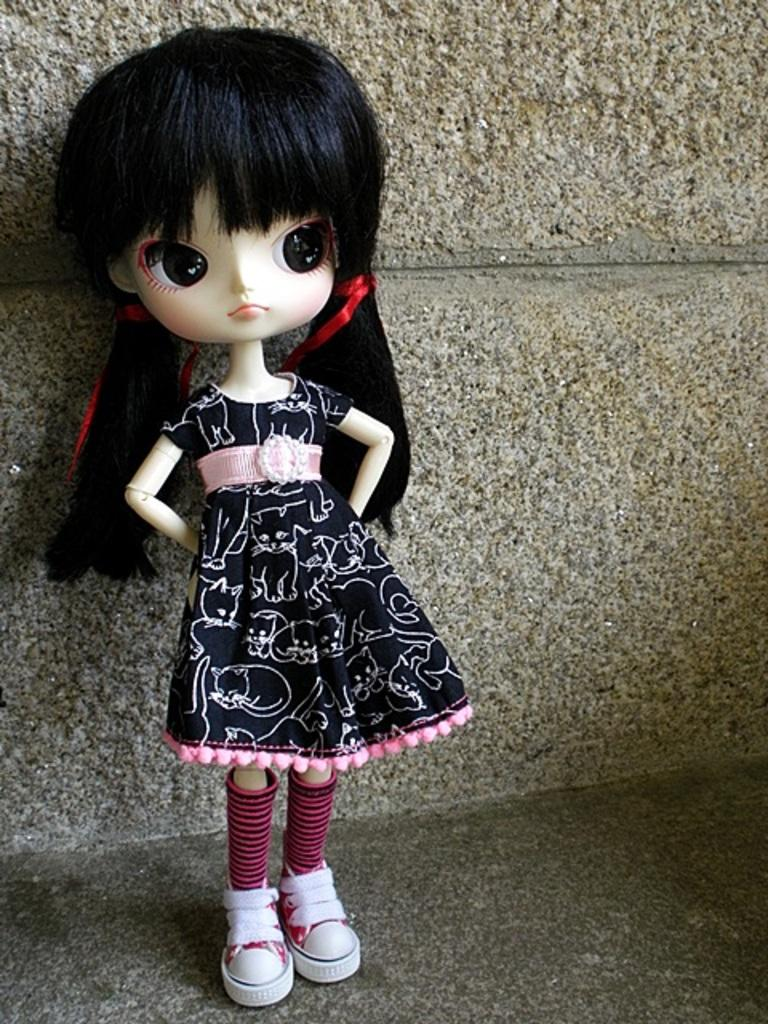What is the main subject in the image? There is a doll in the image. What is the doll doing in the image? The doll is standing. What is the doll wearing in the image? The doll is wearing a black frock, socks, and shoes. What can be seen in the background of the image? There is a wall in the image. What type of magic is the doll performing in the image? There is no magic or any magical activity depicted in the image; the doll is simply standing and wearing specific clothing. 